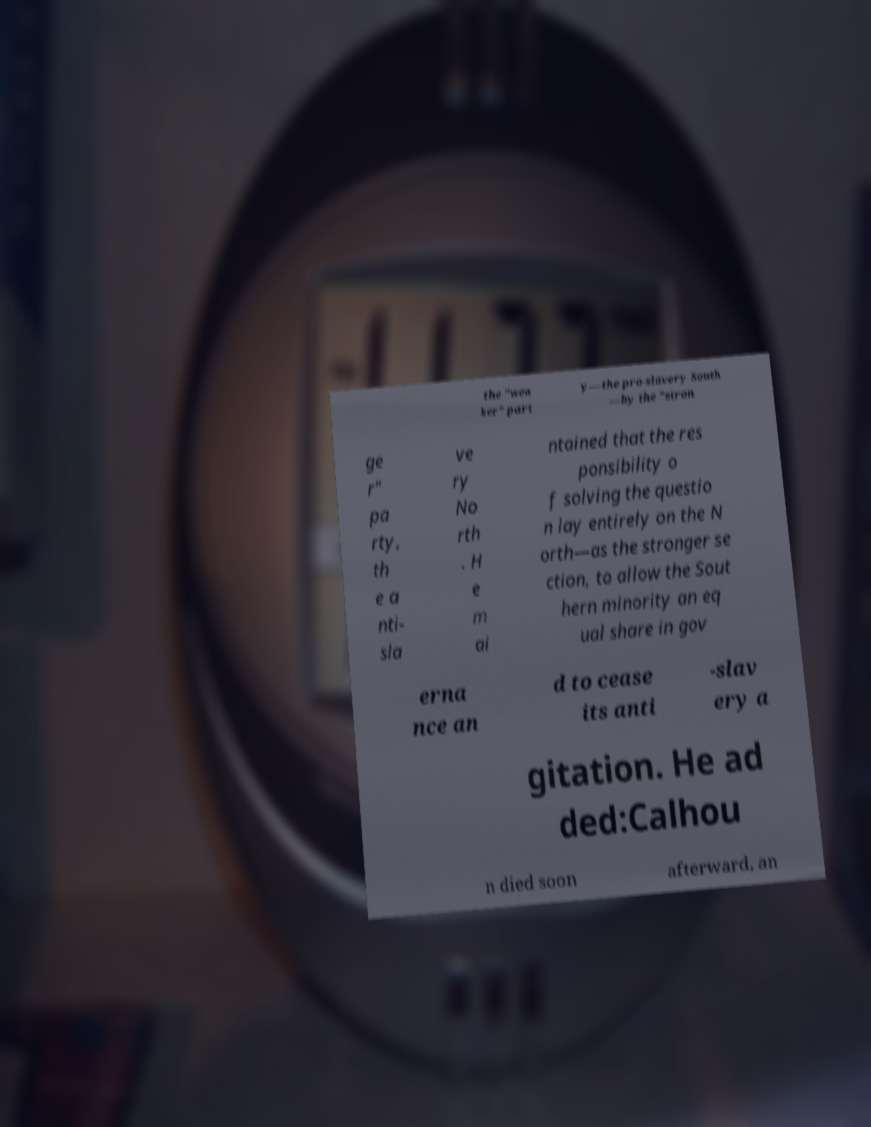Please identify and transcribe the text found in this image. the "wea ker" part y—the pro-slavery South —by the "stron ge r" pa rty, th e a nti- sla ve ry No rth . H e m ai ntained that the res ponsibility o f solving the questio n lay entirely on the N orth—as the stronger se ction, to allow the Sout hern minority an eq ual share in gov erna nce an d to cease its anti -slav ery a gitation. He ad ded:Calhou n died soon afterward, an 